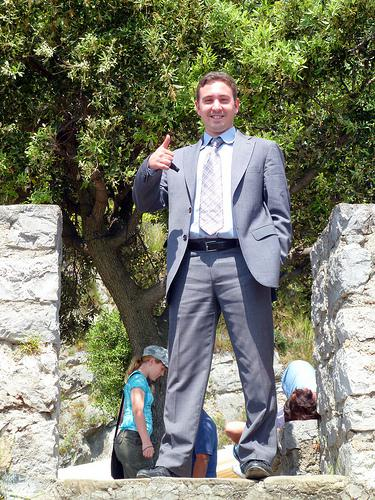Question: what is the man wearing?
Choices:
A. A jacket.
B. A suit.
C. Shorts.
D. A bathing suit.
Answer with the letter. Answer: B Question: what is the man standing on?
Choices:
A. The curb.
B. Stone.
C. A ladder.
D. The street.
Answer with the letter. Answer: B Question: who is in the foreground?
Choices:
A. A woman.
B. A man.
C. The child.
D. No one.
Answer with the letter. Answer: B 